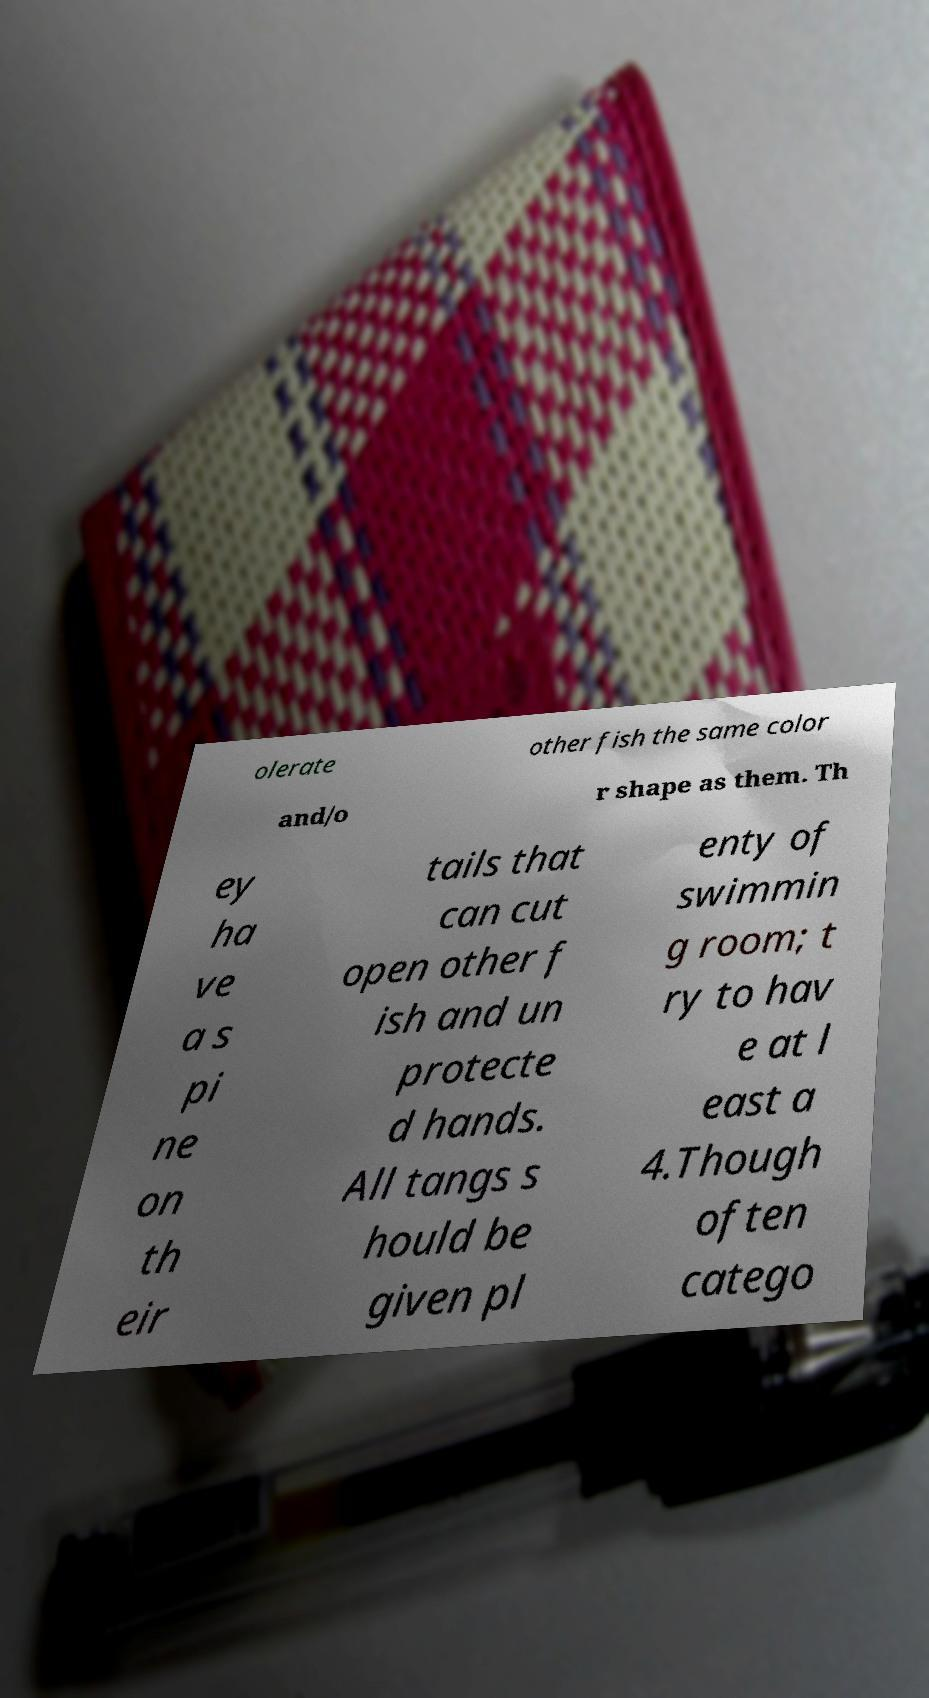I need the written content from this picture converted into text. Can you do that? olerate other fish the same color and/o r shape as them. Th ey ha ve a s pi ne on th eir tails that can cut open other f ish and un protecte d hands. All tangs s hould be given pl enty of swimmin g room; t ry to hav e at l east a 4.Though often catego 